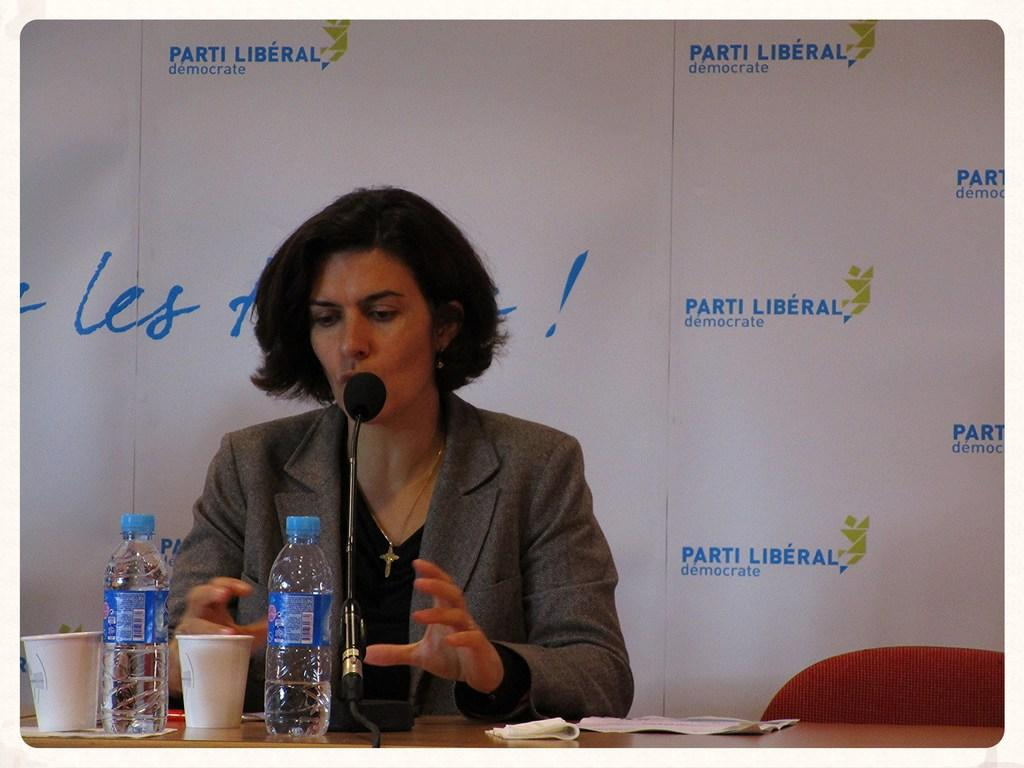Who is the main subject in the image? There is a woman in the image. What is the woman doing in the image? The woman is talking on a microphone. What can be seen on the table in the image? There are bottles, glasses, and papers on the table. What type of furniture is present in the image? There is a chair in the image. What is visible in the background of the image? There is a banner in the background of the image. Where are the cows in the image? There are no cows present in the image. What type of doll is sitting on the table next to the glasses? There is no doll present on the table or in the image. 